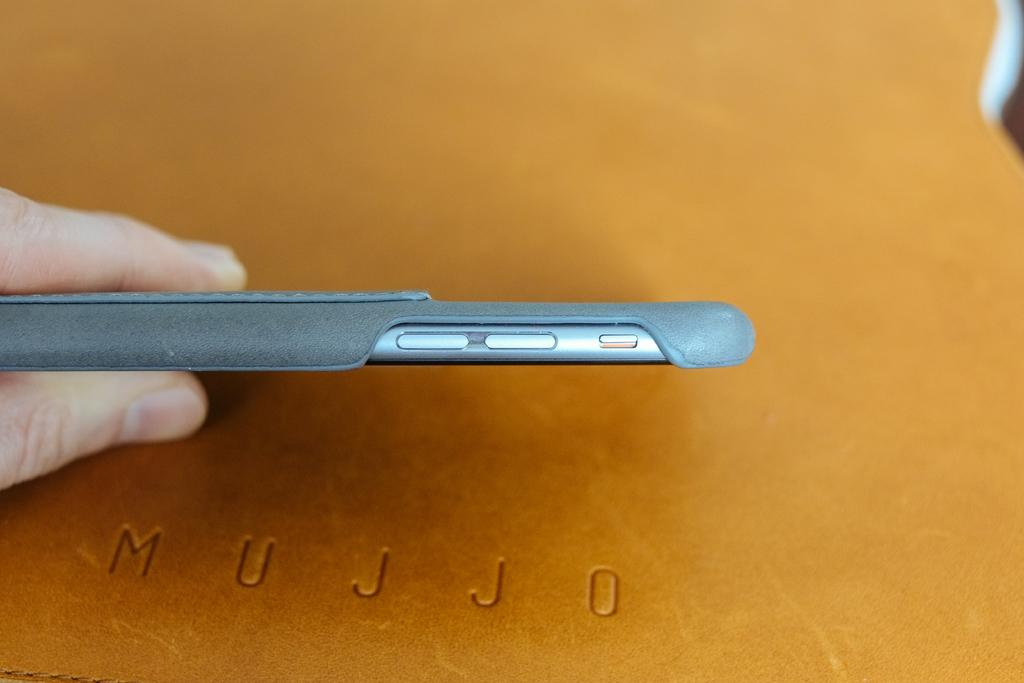<image>
Describe the image concisely. Someone holds a phone over leather with Mujjo carved into it. 